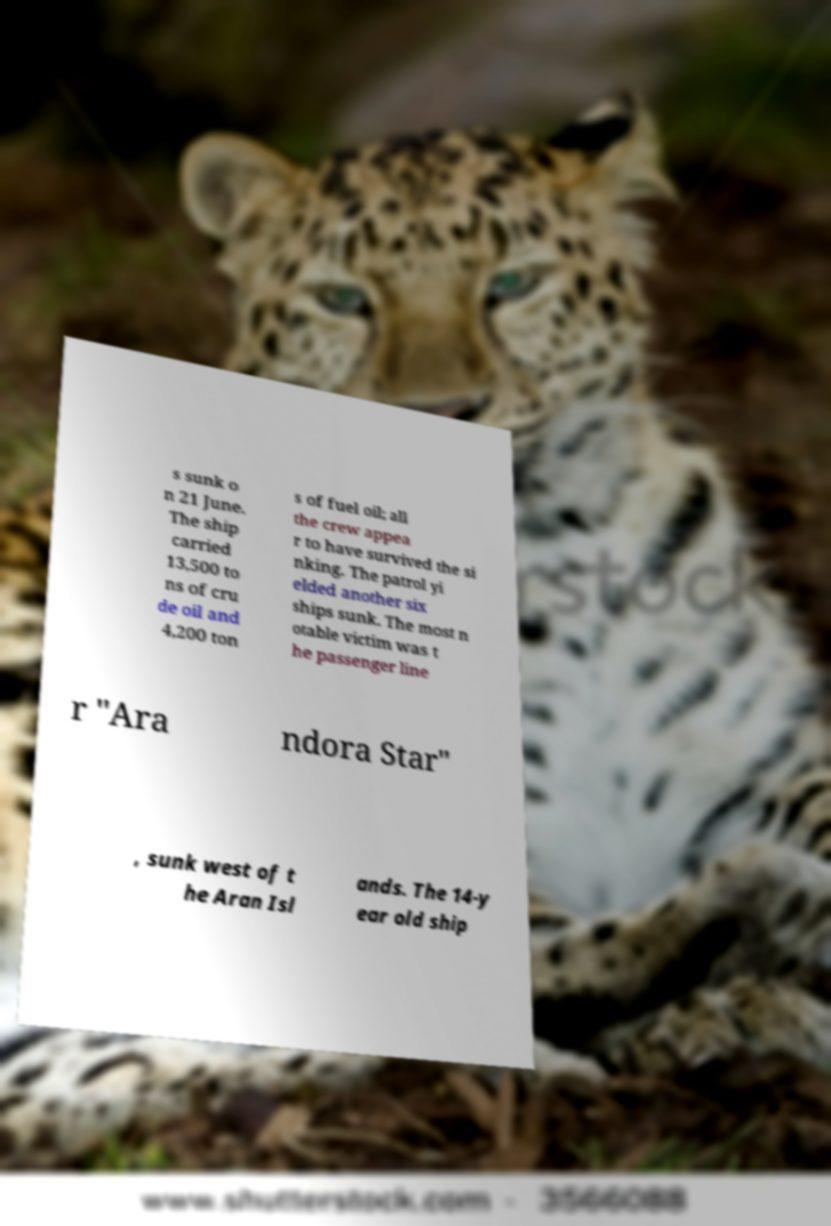What messages or text are displayed in this image? I need them in a readable, typed format. s sunk o n 21 June. The ship carried 13,500 to ns of cru de oil and 4,200 ton s of fuel oil; all the crew appea r to have survived the si nking. The patrol yi elded another six ships sunk. The most n otable victim was t he passenger line r "Ara ndora Star" , sunk west of t he Aran Isl ands. The 14-y ear old ship 